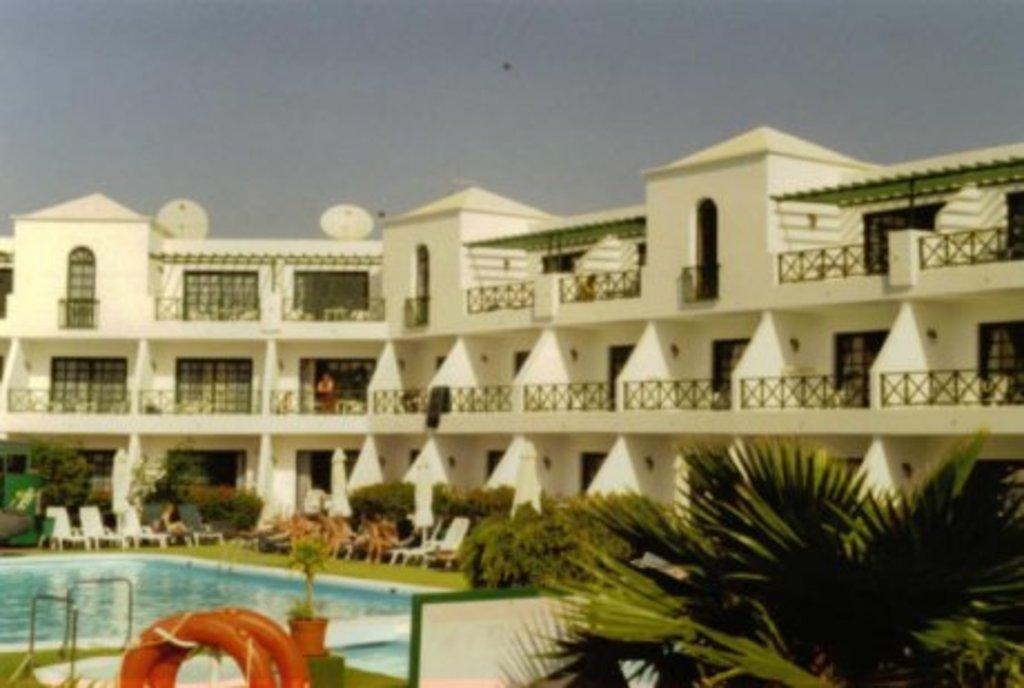What type of vegetation can be seen in the image? There are plants and grass in the image. What structures are present in the image? There are rods, chairs, tubes, a building, satellite dishes, and railings in the image. What is the natural element visible in the image? Water is visible in the image. What architectural feature can be seen in the image? Railings are present in the image. What is visible in the background of the image? The sky is visible in the background of the image. What type of nation is being represented on the stage in the image? There is no stage or nation present in the image. How does the rest of the image relate to the nation being represented on the stage? Since there is no stage or nation present in the image, it is not possible to determine how the rest of the image relates to a nation being represented on a stage. 